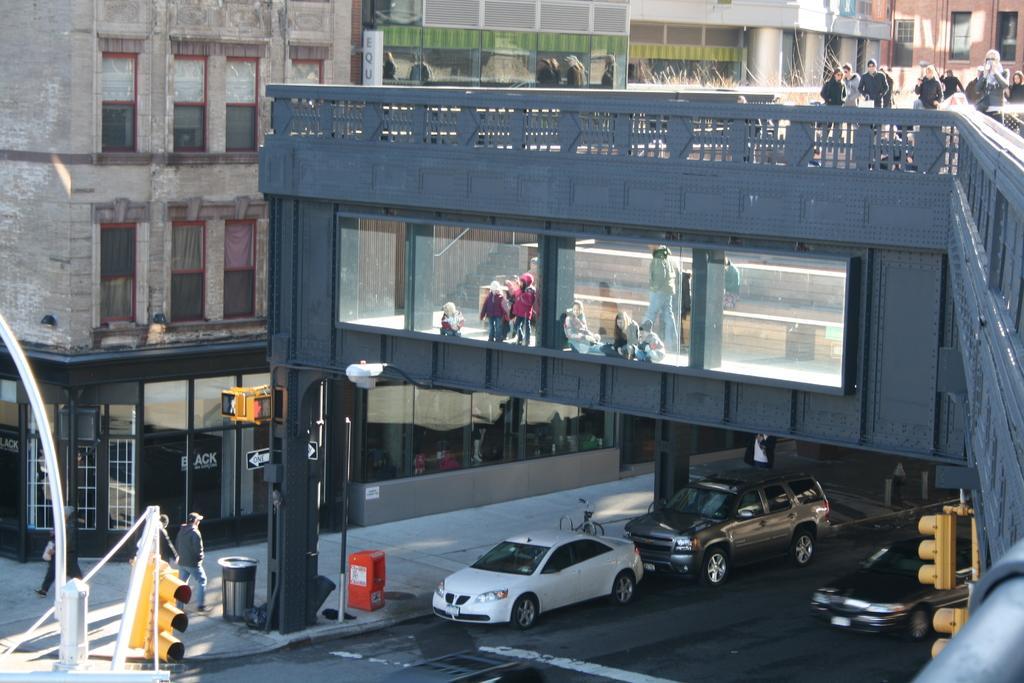Describe this image in one or two sentences. In this image there is a bridge in the middle, On the bridge there are so many people walking on it. At the bottom there is a road on which there are cars. On the left side there is traffic signal light. In the background there are buildings. There is a dustbin on the footpath. There are direction boards on the footpath. 